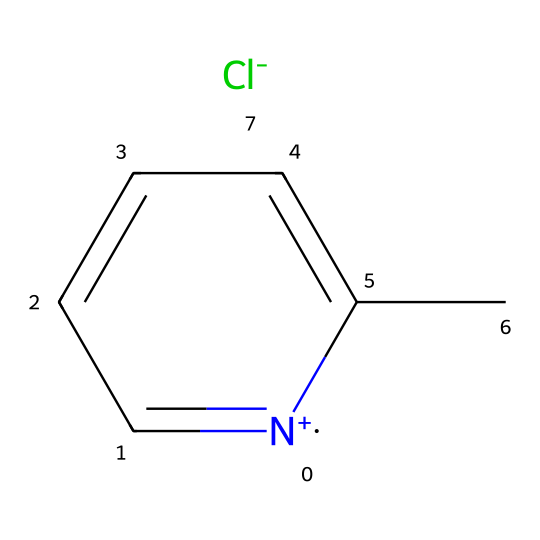what is the cation in this ionic liquid? The cation in this ionic liquid is represented by the pyridinium moiety, which can be identified by the presence of the nitrogen atom in a ring structure, along with the aromatic carbon atoms surrounding it.
Answer: pyridinium how many carbon atoms are present in the chemical structure? By analyzing the SMILES notation, there are five carbon atoms in the pyridinium ring and one additional carbon attached to it, totaling six carbon atoms.
Answer: six what is the chemical's anion? The anion of this ionic liquid is represented by the part of the structure denoted as [Cl-], indicating that it is a chloride ion.
Answer: chloride does this ionic liquid contain any functional groups? There are no traditional functional groups such as hydroxyl or carboxyl in this structure; it is primarily a salt formed between the pyridinium cation and chloride anion.
Answer: none how does the ionic nature of this liquid affect its solubility? The ionic nature of this liquid enhances its solubility in polar solvents due to the interaction between the charged species and polar molecules, increasing its ability to dissolve solutes.
Answer: enhances solubility what property is improved by adding this ionic liquid to traditional Omani halwa? Adding this ionic liquid can help improve the shelf life of traditional Omani halwa due to its ability to act as a preservative by creating a more stable environment against microbial growth.
Answer: shelf life 